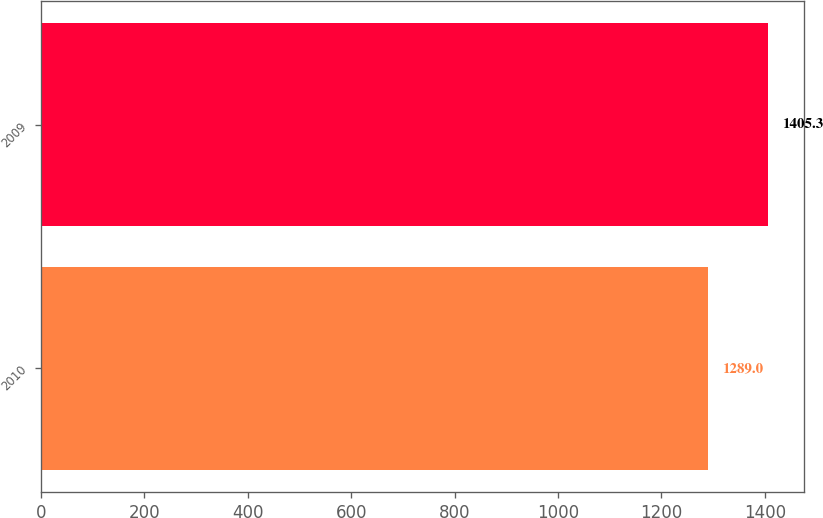<chart> <loc_0><loc_0><loc_500><loc_500><bar_chart><fcel>2010<fcel>2009<nl><fcel>1289<fcel>1405.3<nl></chart> 